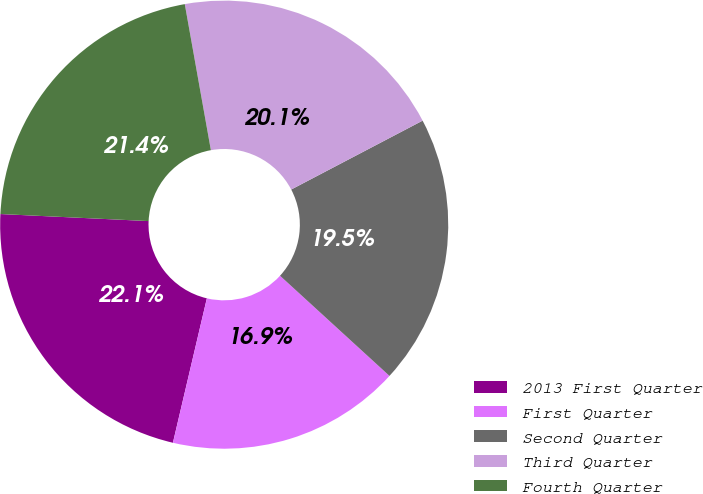Convert chart to OTSL. <chart><loc_0><loc_0><loc_500><loc_500><pie_chart><fcel>2013 First Quarter<fcel>First Quarter<fcel>Second Quarter<fcel>Third Quarter<fcel>Fourth Quarter<nl><fcel>22.08%<fcel>16.88%<fcel>19.48%<fcel>20.13%<fcel>21.43%<nl></chart> 